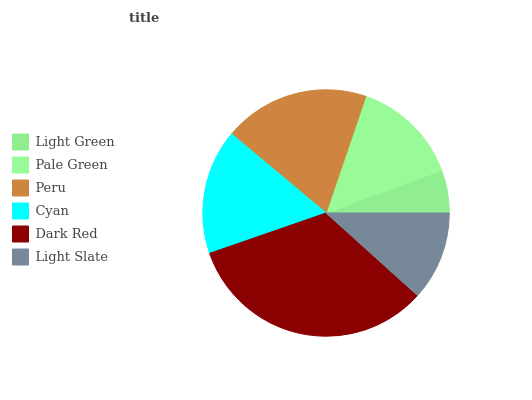Is Light Green the minimum?
Answer yes or no. Yes. Is Dark Red the maximum?
Answer yes or no. Yes. Is Pale Green the minimum?
Answer yes or no. No. Is Pale Green the maximum?
Answer yes or no. No. Is Pale Green greater than Light Green?
Answer yes or no. Yes. Is Light Green less than Pale Green?
Answer yes or no. Yes. Is Light Green greater than Pale Green?
Answer yes or no. No. Is Pale Green less than Light Green?
Answer yes or no. No. Is Cyan the high median?
Answer yes or no. Yes. Is Pale Green the low median?
Answer yes or no. Yes. Is Peru the high median?
Answer yes or no. No. Is Light Green the low median?
Answer yes or no. No. 